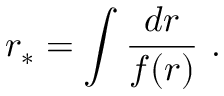Convert formula to latex. <formula><loc_0><loc_0><loc_500><loc_500>r _ { \ast } = \int \frac { d r } { f ( r ) } \ .</formula> 